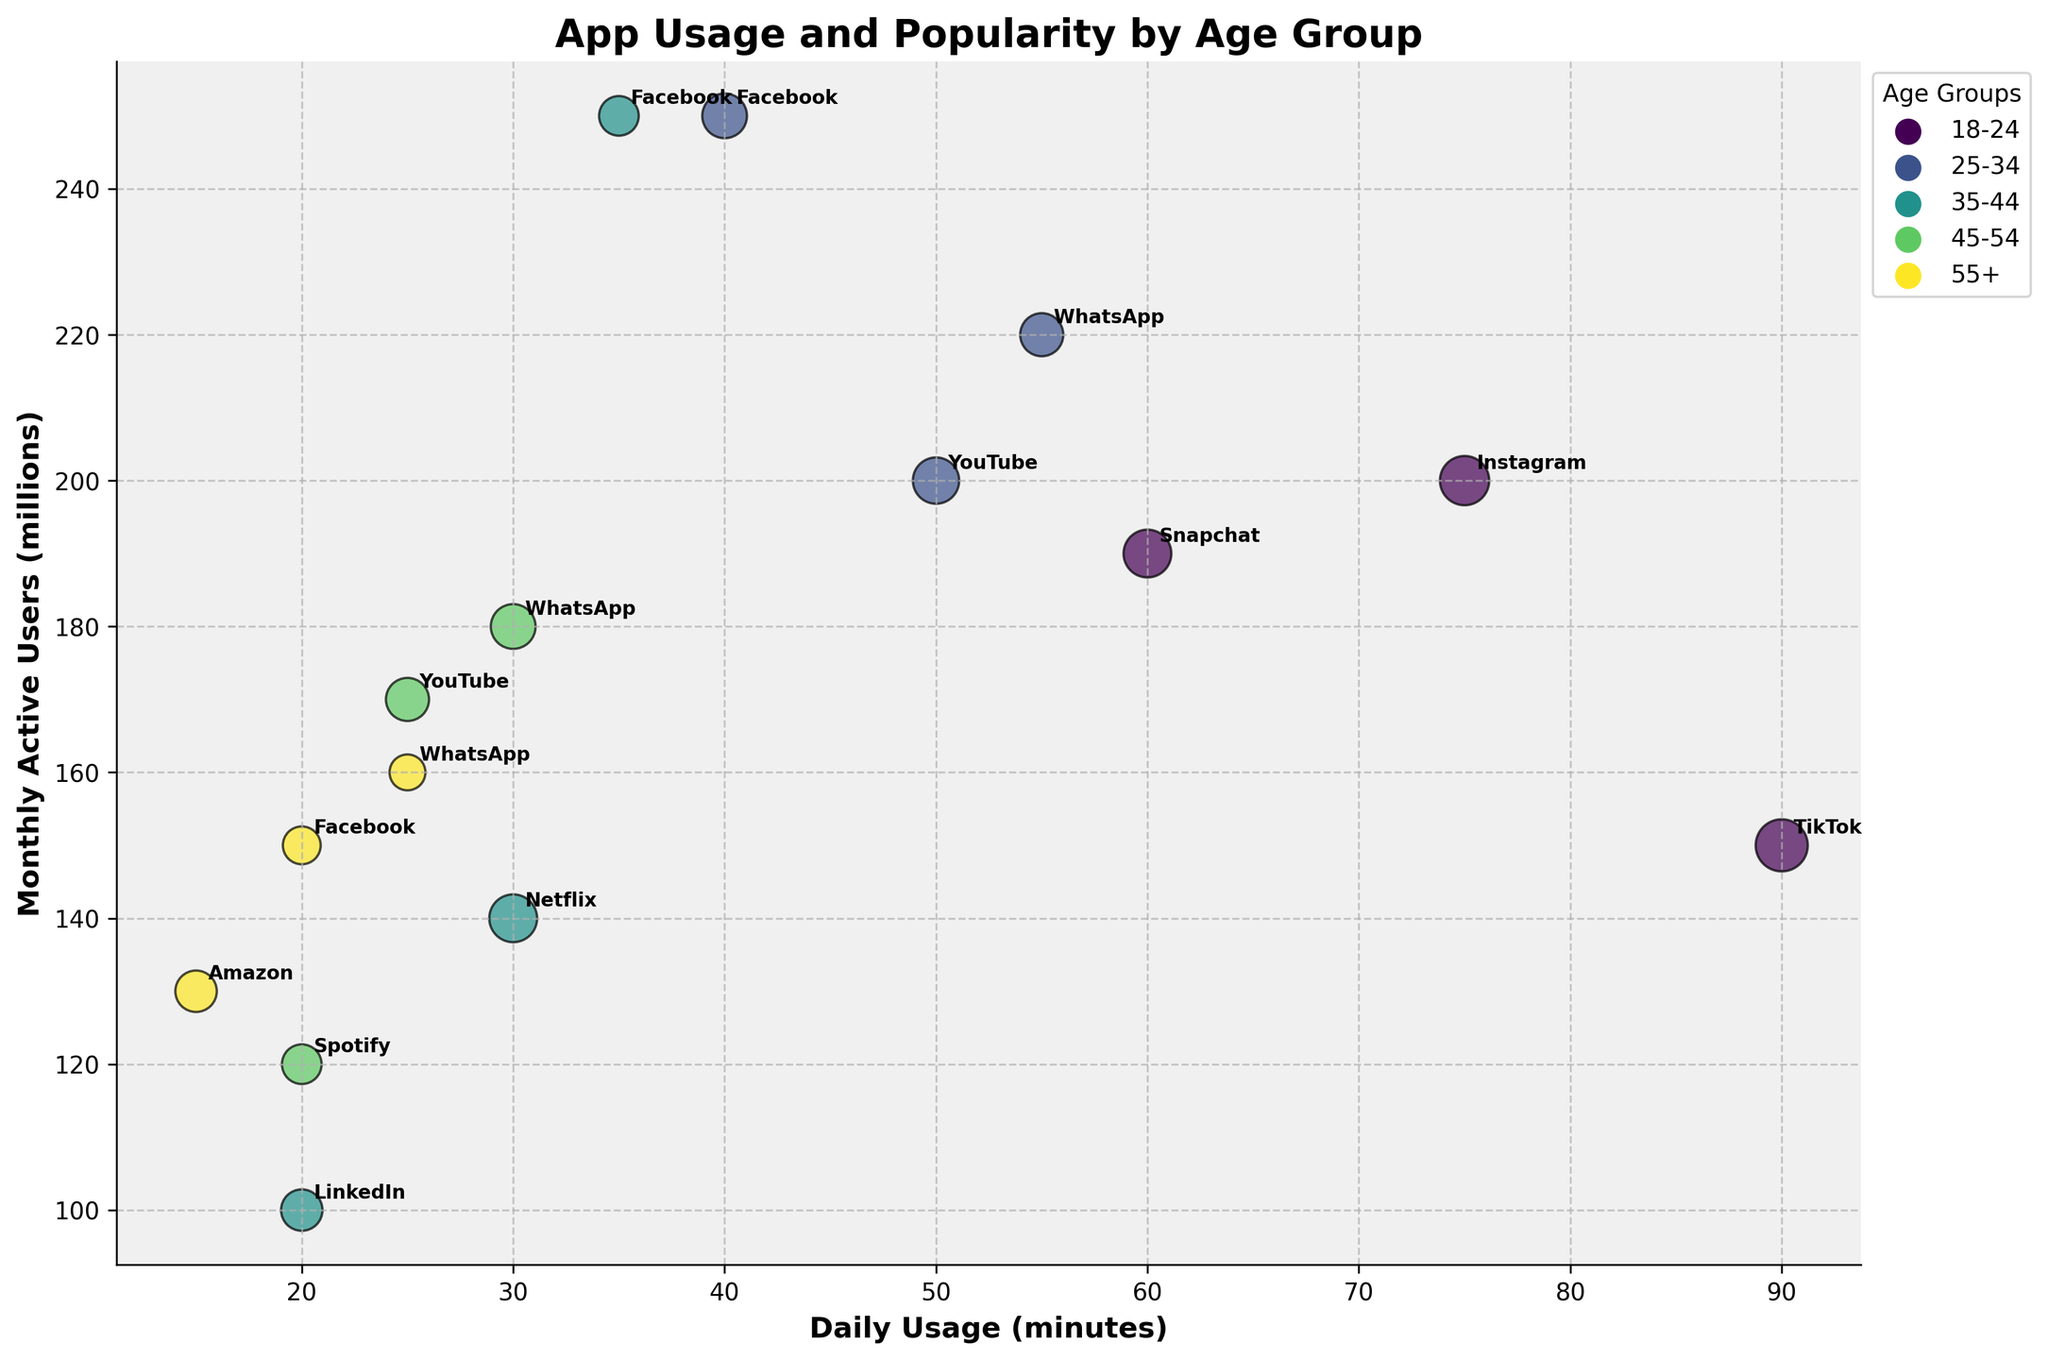What is the title of the figure? The title of the figure is prominently displayed at the top in bold text.
Answer: App Usage and Popularity by Age Group Which age group has the bubble with the largest size? The size of the bubble represents the Feature Usage Percentage, and the largest bubble appears in the 18-24 age group for TikTok.
Answer: 18-24 How many apps are included for the 35-44 age group? By counting the annotations associated with the colored bubbles for the 35-44 age group, you can see that there are 3 apps: LinkedIn, Facebook, and Netflix.
Answer: 3 Which app in the 25-34 age group has the highest Daily Usage (minutes)? By looking at the x-axis for the 25-34 age group bubbles, WhatsApp has the highest daily usage of 55 minutes.
Answer: WhatsApp Which app has the highest Monthly Active Users (millions) across all age groups? By identifying the highest point on the y-axis, Facebook has the highest Monthly Active Users of 250 million.
Answer: Facebook Between Instagram and Snapchat for the 18-24 age group, which app has a higher Feature Usage Percentage? The size of the bubbles indicates Feature Usage Percentage. Comparing Instagram and Snapchat, Instagram's Stories (85%) is larger than Snapchat's Filters (80%).
Answer: Instagram For the apps in the 45-54 age group, what is the average Daily Usage (minutes)? Calculate the average by summing the Daily Usage minutes for WhatsApp (30), YouTube (25), and Spotify (20) and dividing by 3. (30+25+20)/3 = 75/3.
Answer: 25 Which app in the 55+ age group is used the least daily? By looking at the x-axis for all bubbles in the 55+ age group, Amazon has the smallest Daily Usage of 15 minutes.
Answer: Amazon Is there an app that appears in multiple age groups? By analyzing the annotations associated with the bubbles, Facebook appears in multiple age groups: 25-34, 35-44, and 55+.
Answer: Facebook In the 18-24 age group, which app has the fewest Monthly Active Users (millions)? By identifying the bubble with the lowest point on the y-axis within the 18-24 age group, TikTok has the fewest Monthly Active Users at 150 million.
Answer: TikTok 